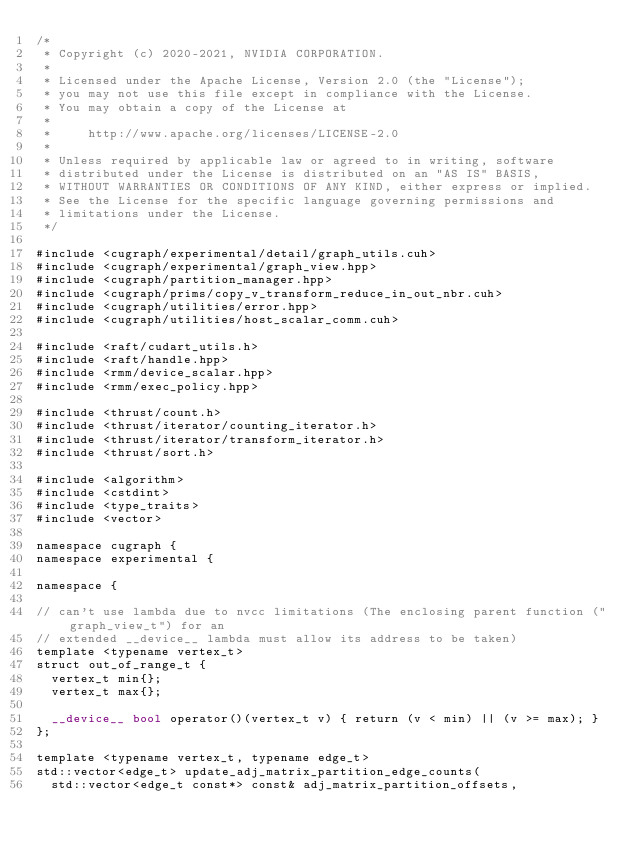<code> <loc_0><loc_0><loc_500><loc_500><_Cuda_>/*
 * Copyright (c) 2020-2021, NVIDIA CORPORATION.
 *
 * Licensed under the Apache License, Version 2.0 (the "License");
 * you may not use this file except in compliance with the License.
 * You may obtain a copy of the License at
 *
 *     http://www.apache.org/licenses/LICENSE-2.0
 *
 * Unless required by applicable law or agreed to in writing, software
 * distributed under the License is distributed on an "AS IS" BASIS,
 * WITHOUT WARRANTIES OR CONDITIONS OF ANY KIND, either express or implied.
 * See the License for the specific language governing permissions and
 * limitations under the License.
 */

#include <cugraph/experimental/detail/graph_utils.cuh>
#include <cugraph/experimental/graph_view.hpp>
#include <cugraph/partition_manager.hpp>
#include <cugraph/prims/copy_v_transform_reduce_in_out_nbr.cuh>
#include <cugraph/utilities/error.hpp>
#include <cugraph/utilities/host_scalar_comm.cuh>

#include <raft/cudart_utils.h>
#include <raft/handle.hpp>
#include <rmm/device_scalar.hpp>
#include <rmm/exec_policy.hpp>

#include <thrust/count.h>
#include <thrust/iterator/counting_iterator.h>
#include <thrust/iterator/transform_iterator.h>
#include <thrust/sort.h>

#include <algorithm>
#include <cstdint>
#include <type_traits>
#include <vector>

namespace cugraph {
namespace experimental {

namespace {

// can't use lambda due to nvcc limitations (The enclosing parent function ("graph_view_t") for an
// extended __device__ lambda must allow its address to be taken)
template <typename vertex_t>
struct out_of_range_t {
  vertex_t min{};
  vertex_t max{};

  __device__ bool operator()(vertex_t v) { return (v < min) || (v >= max); }
};

template <typename vertex_t, typename edge_t>
std::vector<edge_t> update_adj_matrix_partition_edge_counts(
  std::vector<edge_t const*> const& adj_matrix_partition_offsets,</code> 